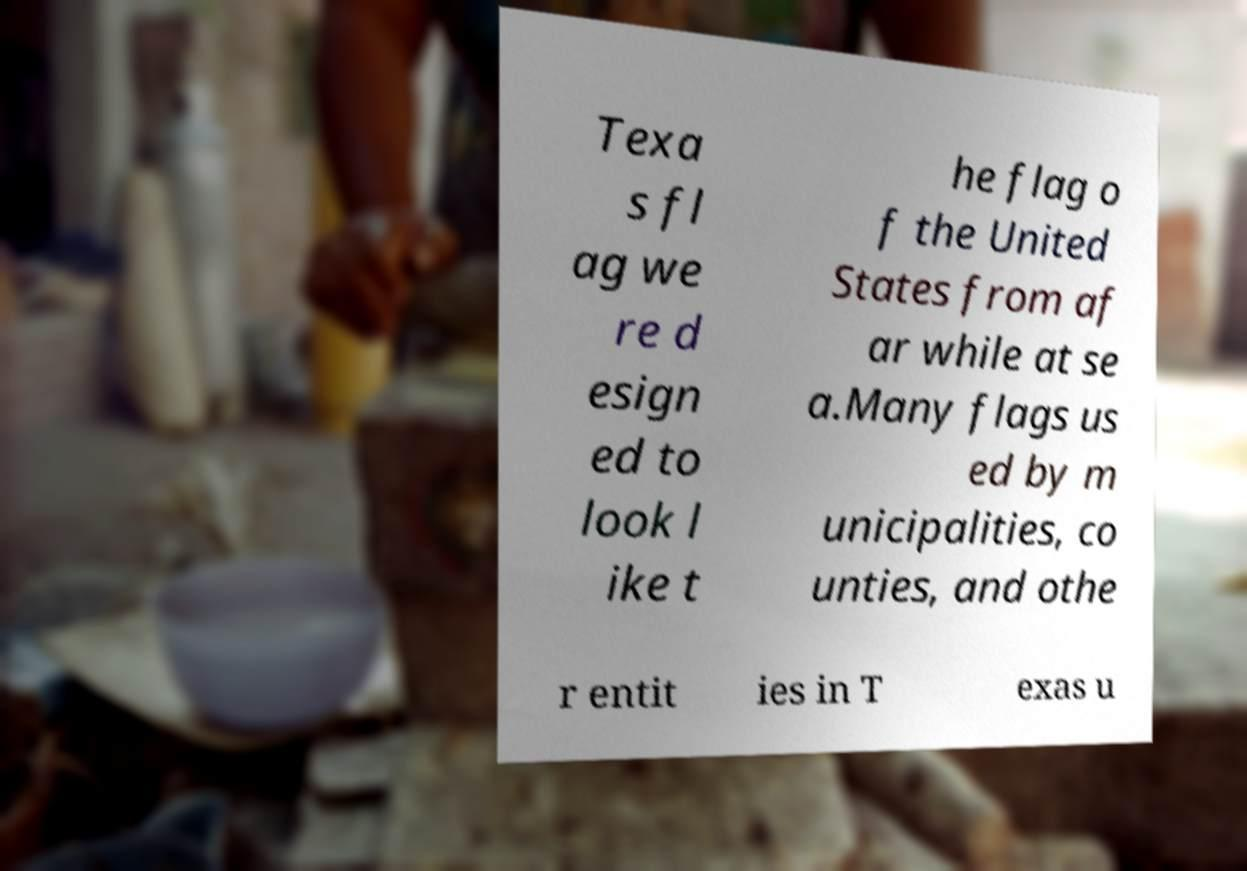Could you extract and type out the text from this image? Texa s fl ag we re d esign ed to look l ike t he flag o f the United States from af ar while at se a.Many flags us ed by m unicipalities, co unties, and othe r entit ies in T exas u 